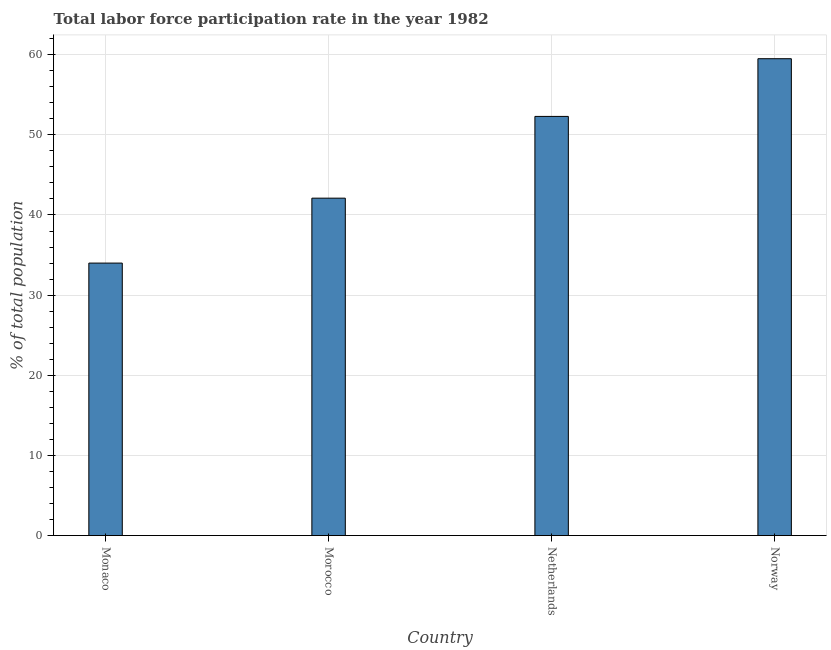Does the graph contain any zero values?
Your answer should be very brief. No. What is the title of the graph?
Make the answer very short. Total labor force participation rate in the year 1982. What is the label or title of the Y-axis?
Ensure brevity in your answer.  % of total population. What is the total labor force participation rate in Morocco?
Give a very brief answer. 42.1. Across all countries, what is the maximum total labor force participation rate?
Give a very brief answer. 59.5. Across all countries, what is the minimum total labor force participation rate?
Your answer should be compact. 34. In which country was the total labor force participation rate maximum?
Ensure brevity in your answer.  Norway. In which country was the total labor force participation rate minimum?
Offer a terse response. Monaco. What is the sum of the total labor force participation rate?
Offer a very short reply. 187.9. What is the average total labor force participation rate per country?
Offer a very short reply. 46.98. What is the median total labor force participation rate?
Give a very brief answer. 47.2. In how many countries, is the total labor force participation rate greater than 32 %?
Offer a terse response. 4. What is the ratio of the total labor force participation rate in Monaco to that in Norway?
Ensure brevity in your answer.  0.57. Is the total labor force participation rate in Netherlands less than that in Norway?
Offer a very short reply. Yes. Is the difference between the total labor force participation rate in Morocco and Norway greater than the difference between any two countries?
Give a very brief answer. No. What is the difference between the highest and the second highest total labor force participation rate?
Keep it short and to the point. 7.2. In how many countries, is the total labor force participation rate greater than the average total labor force participation rate taken over all countries?
Make the answer very short. 2. How many countries are there in the graph?
Provide a succinct answer. 4. Are the values on the major ticks of Y-axis written in scientific E-notation?
Your response must be concise. No. What is the % of total population of Monaco?
Provide a succinct answer. 34. What is the % of total population of Morocco?
Offer a very short reply. 42.1. What is the % of total population of Netherlands?
Your answer should be very brief. 52.3. What is the % of total population of Norway?
Give a very brief answer. 59.5. What is the difference between the % of total population in Monaco and Netherlands?
Your answer should be compact. -18.3. What is the difference between the % of total population in Monaco and Norway?
Your answer should be very brief. -25.5. What is the difference between the % of total population in Morocco and Netherlands?
Your answer should be very brief. -10.2. What is the difference between the % of total population in Morocco and Norway?
Your response must be concise. -17.4. What is the ratio of the % of total population in Monaco to that in Morocco?
Provide a short and direct response. 0.81. What is the ratio of the % of total population in Monaco to that in Netherlands?
Give a very brief answer. 0.65. What is the ratio of the % of total population in Monaco to that in Norway?
Your answer should be very brief. 0.57. What is the ratio of the % of total population in Morocco to that in Netherlands?
Make the answer very short. 0.81. What is the ratio of the % of total population in Morocco to that in Norway?
Ensure brevity in your answer.  0.71. What is the ratio of the % of total population in Netherlands to that in Norway?
Your response must be concise. 0.88. 